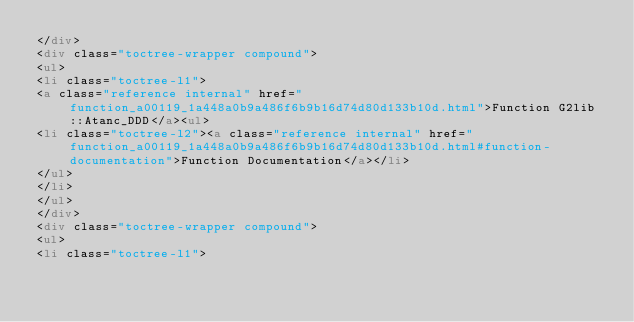<code> <loc_0><loc_0><loc_500><loc_500><_HTML_></div>
<div class="toctree-wrapper compound">
<ul>
<li class="toctree-l1">
<a class="reference internal" href="function_a00119_1a448a0b9a486f6b9b16d74d80d133b10d.html">Function G2lib::Atanc_DDD</a><ul>
<li class="toctree-l2"><a class="reference internal" href="function_a00119_1a448a0b9a486f6b9b16d74d80d133b10d.html#function-documentation">Function Documentation</a></li>
</ul>
</li>
</ul>
</div>
<div class="toctree-wrapper compound">
<ul>
<li class="toctree-l1"></code> 